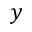<formula> <loc_0><loc_0><loc_500><loc_500>y</formula> 